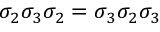Convert formula to latex. <formula><loc_0><loc_0><loc_500><loc_500>\sigma _ { 2 } \sigma _ { 3 } \sigma _ { 2 } = \sigma _ { 3 } \sigma _ { 2 } \sigma _ { 3 }</formula> 